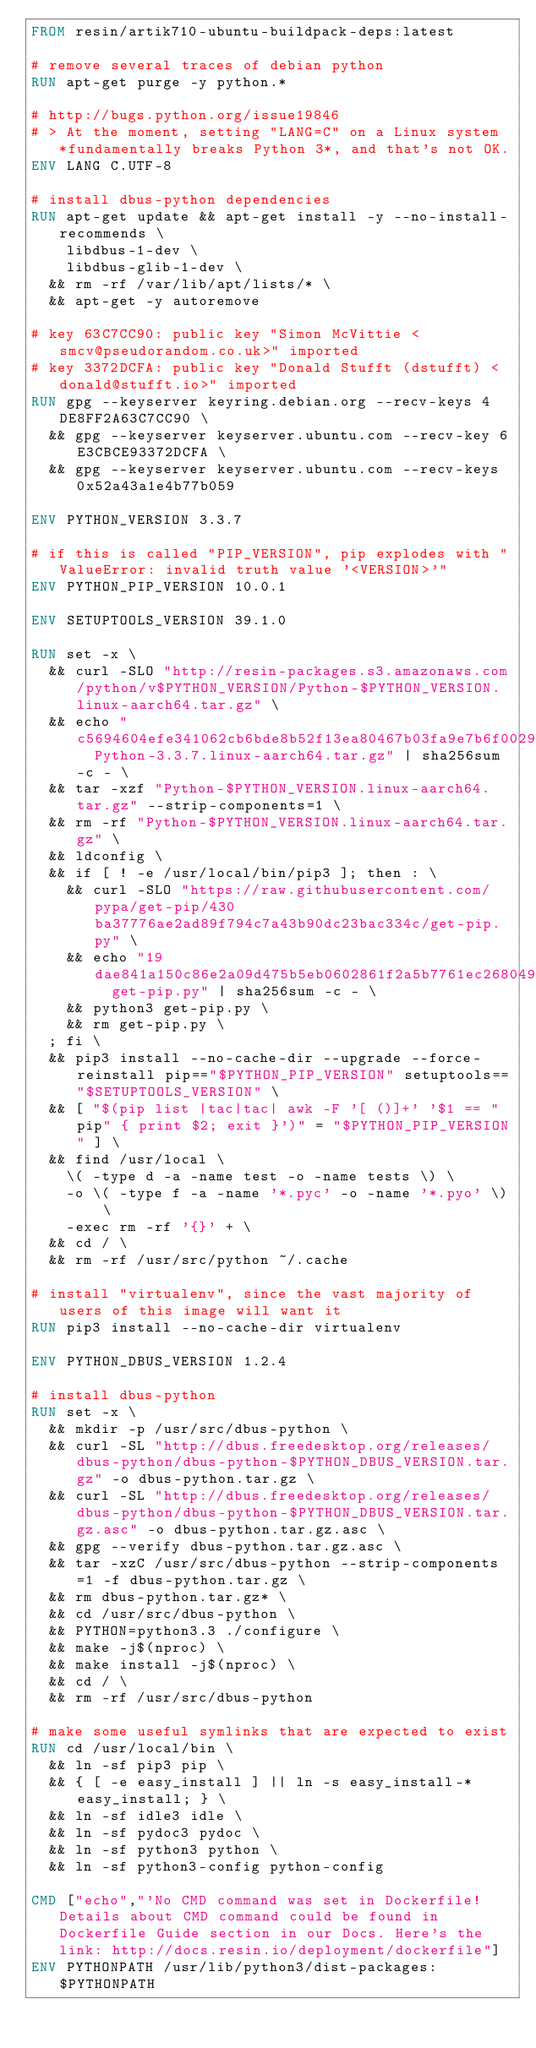Convert code to text. <code><loc_0><loc_0><loc_500><loc_500><_Dockerfile_>FROM resin/artik710-ubuntu-buildpack-deps:latest

# remove several traces of debian python
RUN apt-get purge -y python.*

# http://bugs.python.org/issue19846
# > At the moment, setting "LANG=C" on a Linux system *fundamentally breaks Python 3*, and that's not OK.
ENV LANG C.UTF-8

# install dbus-python dependencies 
RUN apt-get update && apt-get install -y --no-install-recommends \
		libdbus-1-dev \
		libdbus-glib-1-dev \
	&& rm -rf /var/lib/apt/lists/* \
	&& apt-get -y autoremove

# key 63C7CC90: public key "Simon McVittie <smcv@pseudorandom.co.uk>" imported
# key 3372DCFA: public key "Donald Stufft (dstufft) <donald@stufft.io>" imported
RUN gpg --keyserver keyring.debian.org --recv-keys 4DE8FF2A63C7CC90 \
	&& gpg --keyserver keyserver.ubuntu.com --recv-key 6E3CBCE93372DCFA \
	&& gpg --keyserver keyserver.ubuntu.com --recv-keys 0x52a43a1e4b77b059

ENV PYTHON_VERSION 3.3.7

# if this is called "PIP_VERSION", pip explodes with "ValueError: invalid truth value '<VERSION>'"
ENV PYTHON_PIP_VERSION 10.0.1

ENV SETUPTOOLS_VERSION 39.1.0

RUN set -x \
	&& curl -SLO "http://resin-packages.s3.amazonaws.com/python/v$PYTHON_VERSION/Python-$PYTHON_VERSION.linux-aarch64.tar.gz" \
	&& echo "c5694604efe341062cb6bde8b52f13ea80467b03fa9e7b6f002992ae44ce612e  Python-3.3.7.linux-aarch64.tar.gz" | sha256sum -c - \
	&& tar -xzf "Python-$PYTHON_VERSION.linux-aarch64.tar.gz" --strip-components=1 \
	&& rm -rf "Python-$PYTHON_VERSION.linux-aarch64.tar.gz" \
	&& ldconfig \
	&& if [ ! -e /usr/local/bin/pip3 ]; then : \
		&& curl -SLO "https://raw.githubusercontent.com/pypa/get-pip/430ba37776ae2ad89f794c7a43b90dc23bac334c/get-pip.py" \
		&& echo "19dae841a150c86e2a09d475b5eb0602861f2a5b7761ec268049a662dbd2bd0c  get-pip.py" | sha256sum -c - \
		&& python3 get-pip.py \
		&& rm get-pip.py \
	; fi \
	&& pip3 install --no-cache-dir --upgrade --force-reinstall pip=="$PYTHON_PIP_VERSION" setuptools=="$SETUPTOOLS_VERSION" \
	&& [ "$(pip list |tac|tac| awk -F '[ ()]+' '$1 == "pip" { print $2; exit }')" = "$PYTHON_PIP_VERSION" ] \
	&& find /usr/local \
		\( -type d -a -name test -o -name tests \) \
		-o \( -type f -a -name '*.pyc' -o -name '*.pyo' \) \
		-exec rm -rf '{}' + \
	&& cd / \
	&& rm -rf /usr/src/python ~/.cache

# install "virtualenv", since the vast majority of users of this image will want it
RUN pip3 install --no-cache-dir virtualenv

ENV PYTHON_DBUS_VERSION 1.2.4

# install dbus-python
RUN set -x \
	&& mkdir -p /usr/src/dbus-python \
	&& curl -SL "http://dbus.freedesktop.org/releases/dbus-python/dbus-python-$PYTHON_DBUS_VERSION.tar.gz" -o dbus-python.tar.gz \
	&& curl -SL "http://dbus.freedesktop.org/releases/dbus-python/dbus-python-$PYTHON_DBUS_VERSION.tar.gz.asc" -o dbus-python.tar.gz.asc \
	&& gpg --verify dbus-python.tar.gz.asc \
	&& tar -xzC /usr/src/dbus-python --strip-components=1 -f dbus-python.tar.gz \
	&& rm dbus-python.tar.gz* \
	&& cd /usr/src/dbus-python \
	&& PYTHON=python3.3 ./configure \
	&& make -j$(nproc) \
	&& make install -j$(nproc) \
	&& cd / \
	&& rm -rf /usr/src/dbus-python

# make some useful symlinks that are expected to exist
RUN cd /usr/local/bin \
	&& ln -sf pip3 pip \
	&& { [ -e easy_install ] || ln -s easy_install-* easy_install; } \
	&& ln -sf idle3 idle \
	&& ln -sf pydoc3 pydoc \
	&& ln -sf python3 python \
	&& ln -sf python3-config python-config

CMD ["echo","'No CMD command was set in Dockerfile! Details about CMD command could be found in Dockerfile Guide section in our Docs. Here's the link: http://docs.resin.io/deployment/dockerfile"]
ENV PYTHONPATH /usr/lib/python3/dist-packages:$PYTHONPATH
</code> 